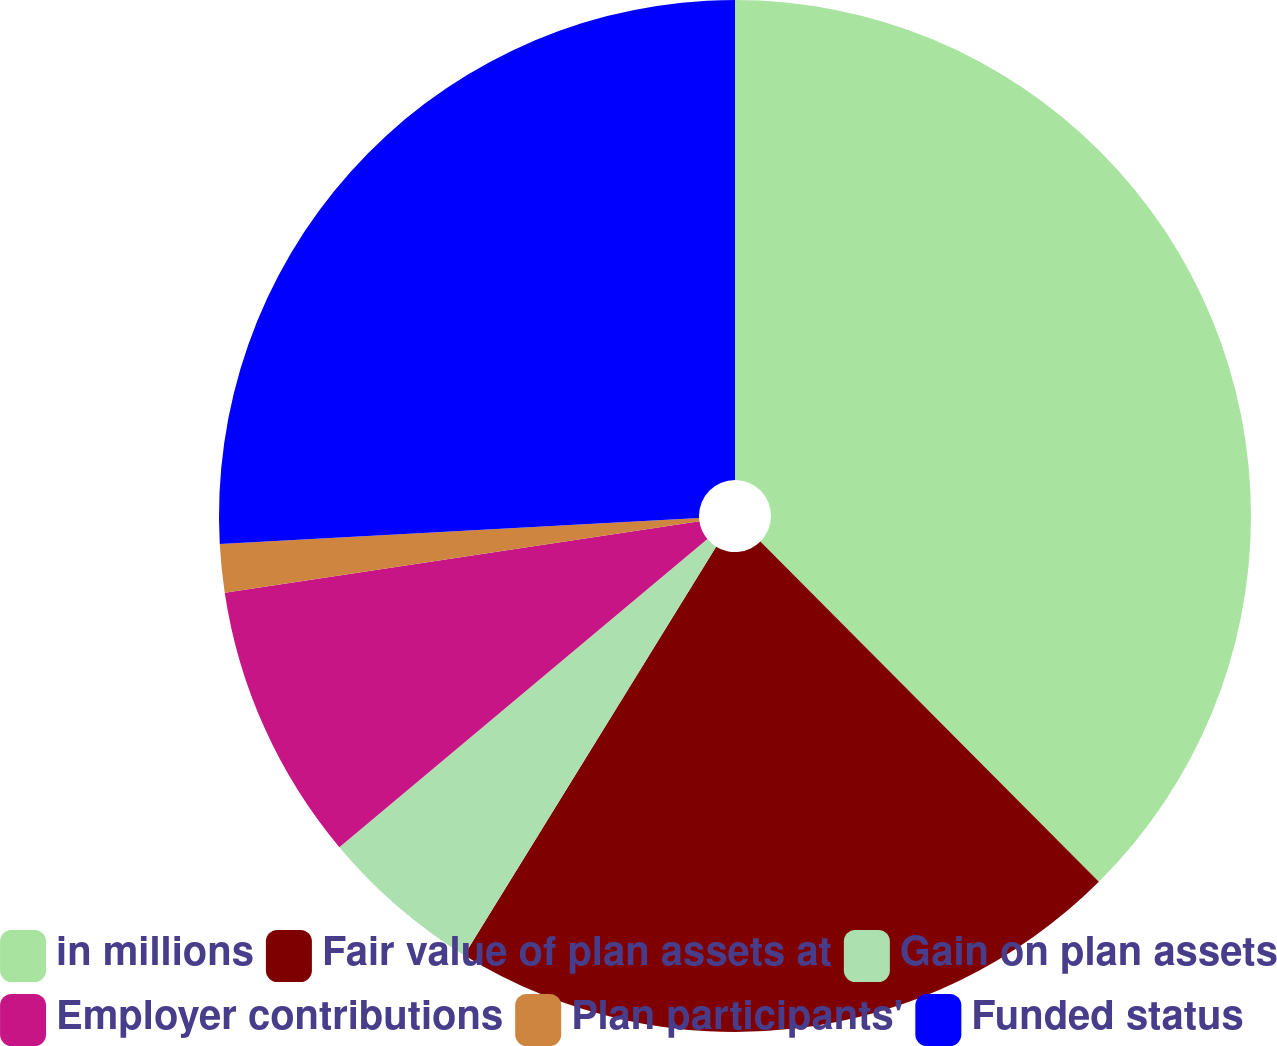Convert chart to OTSL. <chart><loc_0><loc_0><loc_500><loc_500><pie_chart><fcel>in millions<fcel>Fair value of plan assets at<fcel>Gain on plan assets<fcel>Employer contributions<fcel>Plan participants'<fcel>Funded status<nl><fcel>37.54%<fcel>21.25%<fcel>5.11%<fcel>8.72%<fcel>1.51%<fcel>25.86%<nl></chart> 